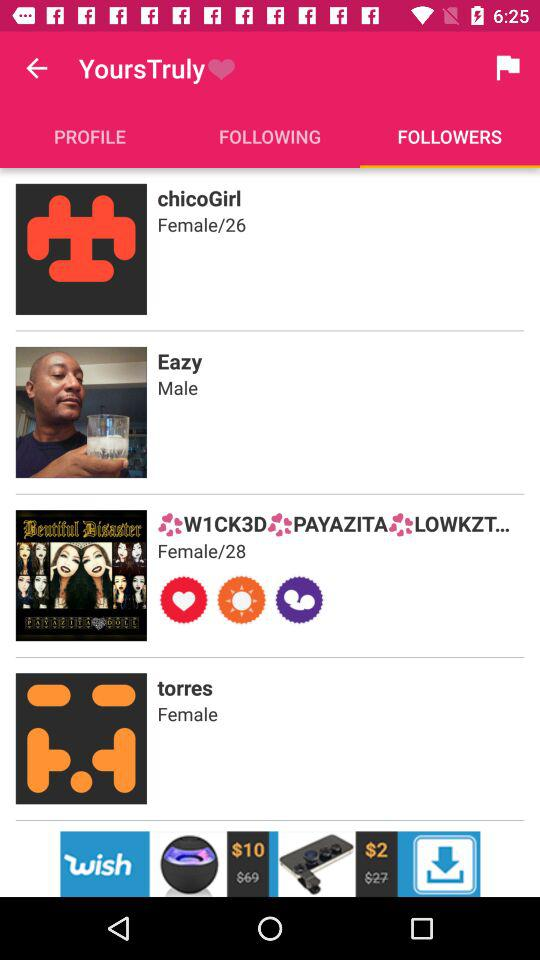What is the username of the female who is 28 years old? The username is "W1CK3DPAYAZITALOWKZT...". 